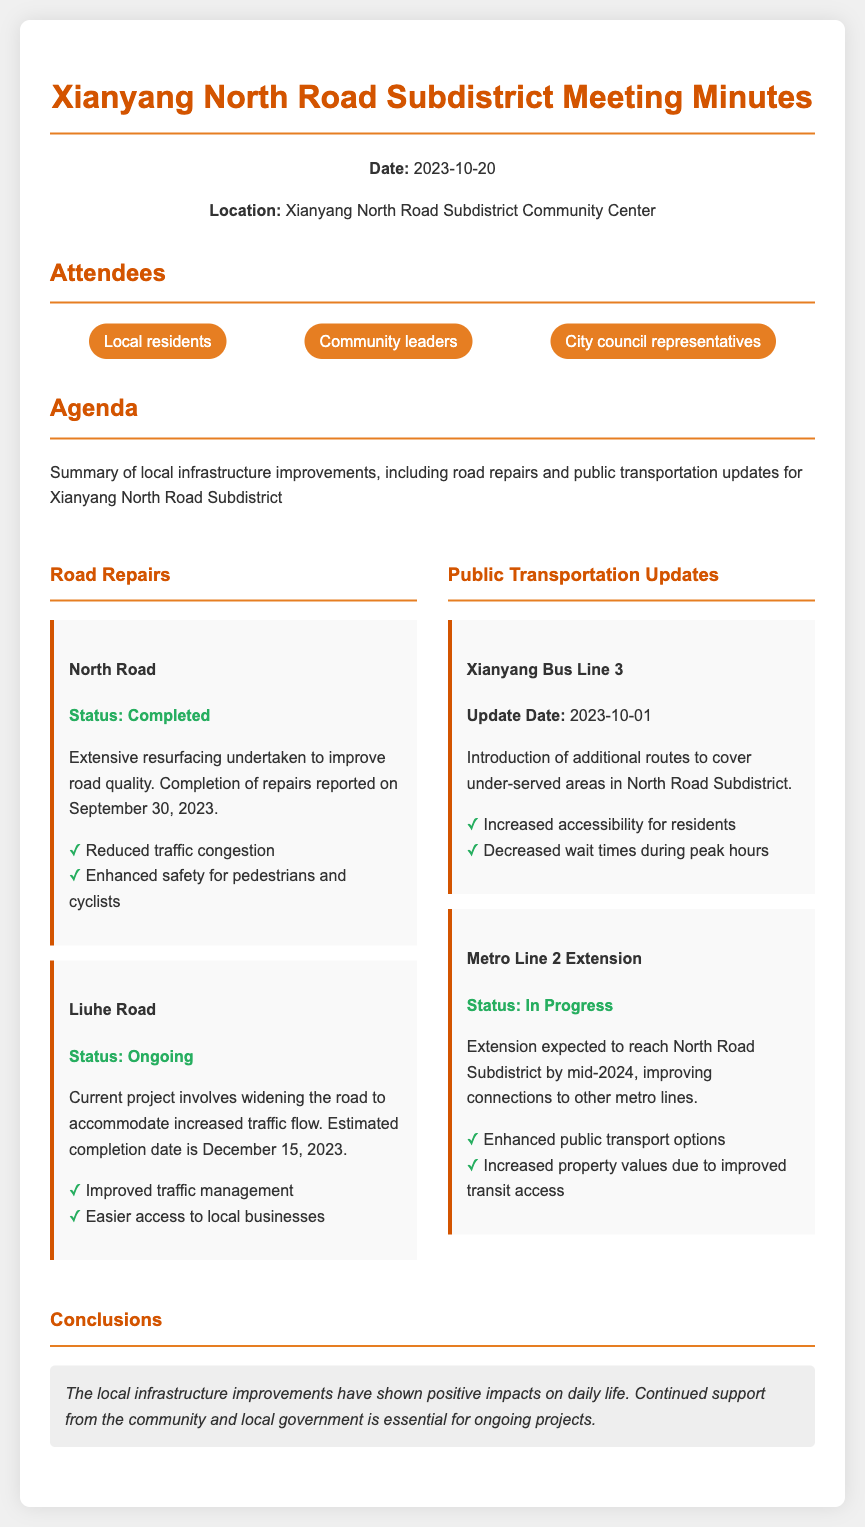What is the date of the meeting? The date of the meeting is provided in the header section of the document.
Answer: 2023-10-20 What road was completed on September 30, 2023? The document specifies the road that underwent resurfacing and its completion date.
Answer: North Road What is the estimated completion date for Liuhe Road repairs? The document lists the estimated completion date for the ongoing Liuhe Road project.
Answer: December 15, 2023 What is the status of Metro Line 2 Extension? The document explicitly states the current status of the metro project.
Answer: In Progress Which bus line was updated on October 1, 2023? The document includes specific details about public transportation updates, including the update date.
Answer: Xianyang Bus Line 3 What is one benefit of the North Road repairs mentioned? The document provides a list of benefits related to the road repairs.
Answer: Enhanced safety for pedestrians and cyclists How many groups of attendees are mentioned in the document? The document outlines the categories of attendees present at the meeting.
Answer: Three What is the main agenda of the meeting? The document summarizes the main topic discussed during the meeting.
Answer: Summary of local infrastructure improvements 